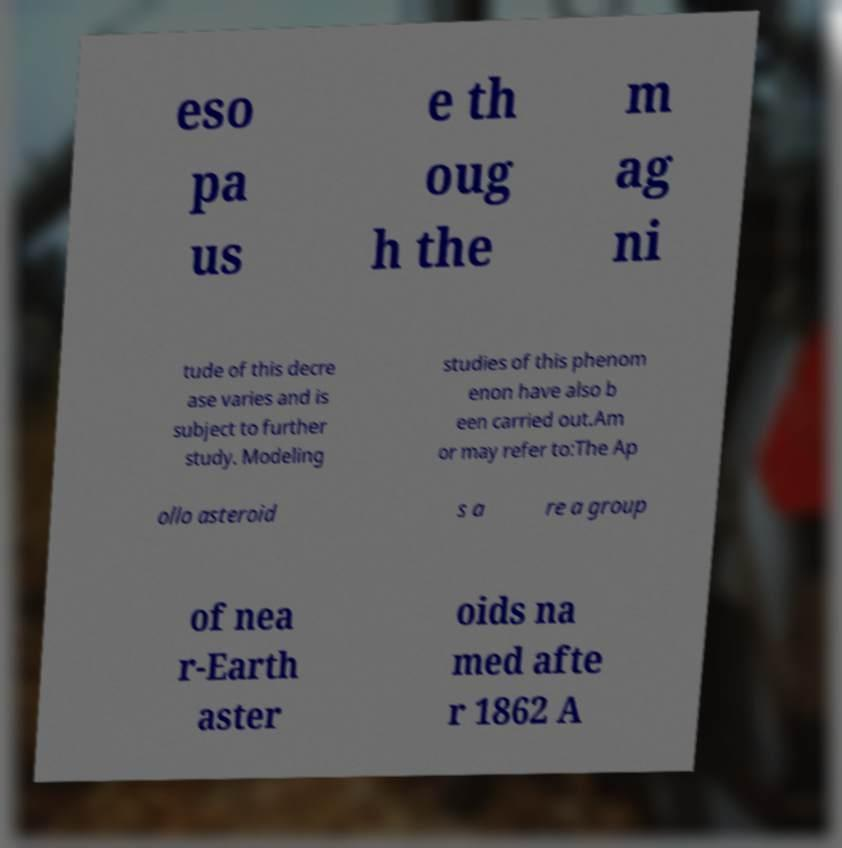Could you extract and type out the text from this image? eso pa us e th oug h the m ag ni tude of this decre ase varies and is subject to further study. Modeling studies of this phenom enon have also b een carried out.Am or may refer to:The Ap ollo asteroid s a re a group of nea r-Earth aster oids na med afte r 1862 A 